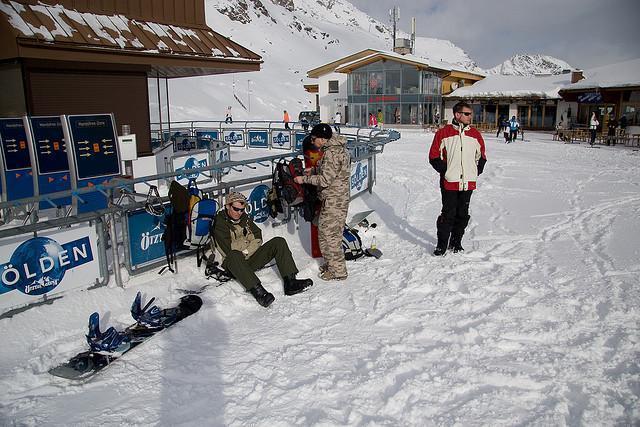How many people are there?
Give a very brief answer. 3. 